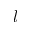Convert formula to latex. <formula><loc_0><loc_0><loc_500><loc_500>l</formula> 